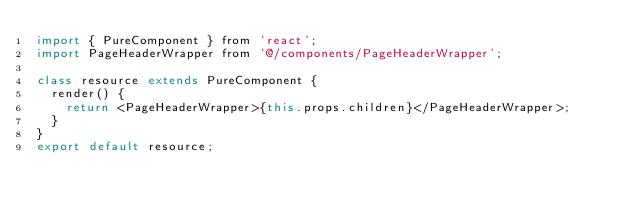<code> <loc_0><loc_0><loc_500><loc_500><_JavaScript_>import { PureComponent } from 'react';
import PageHeaderWrapper from '@/components/PageHeaderWrapper';

class resource extends PureComponent {
  render() {
    return <PageHeaderWrapper>{this.props.children}</PageHeaderWrapper>;
  }
}
export default resource;
</code> 